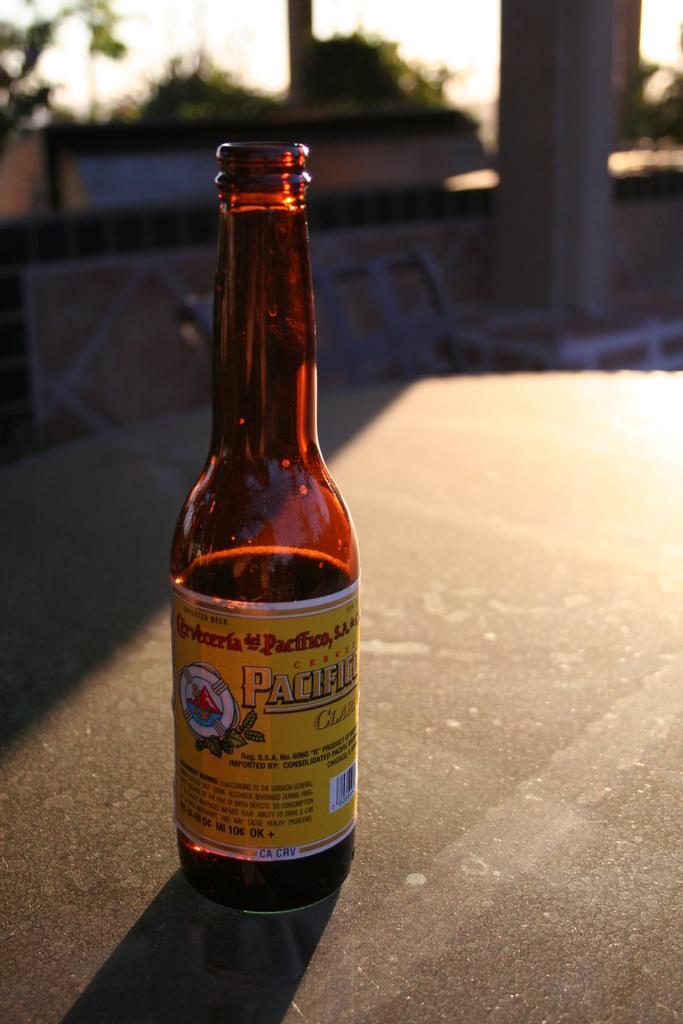<image>
Present a compact description of the photo's key features. A returnable glass bottle of imported Cerveza sits on a table in the sun. 